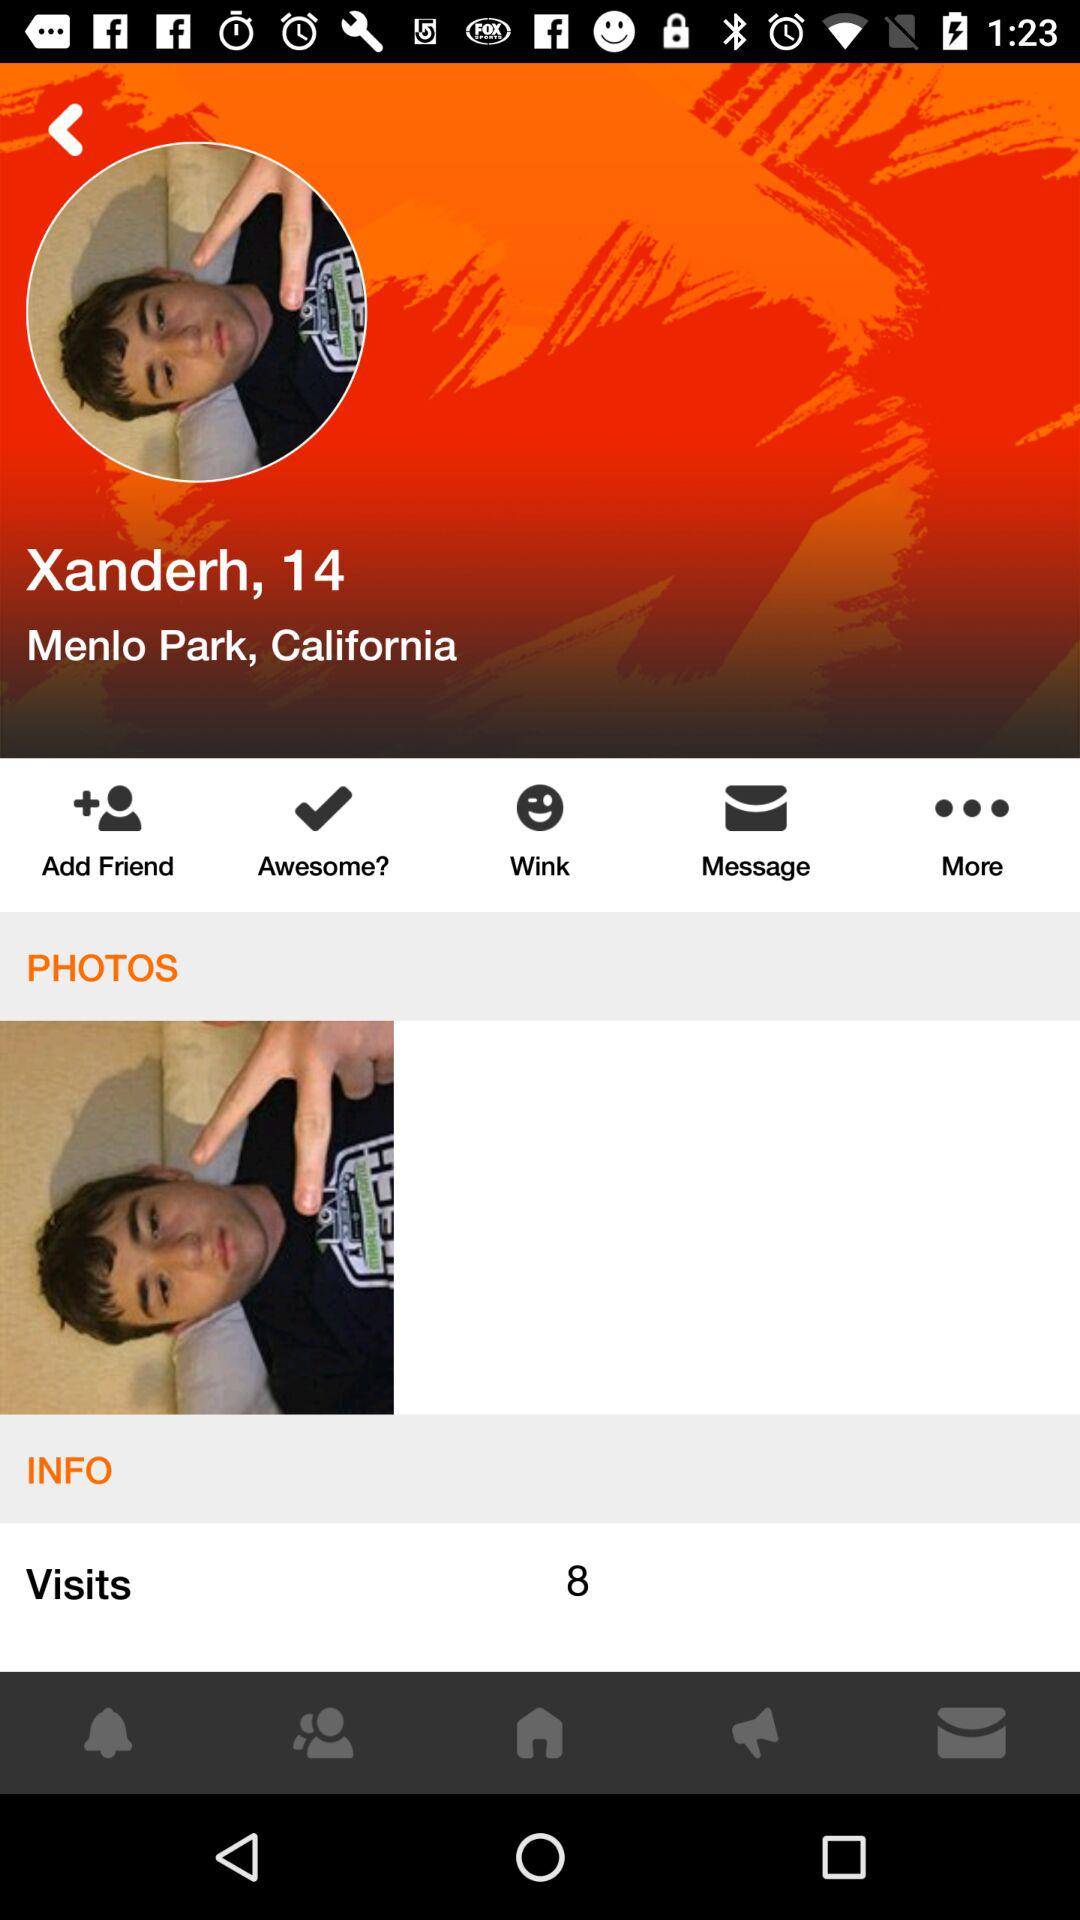How many visits does Xanderh have?
Answer the question using a single word or phrase. 8 